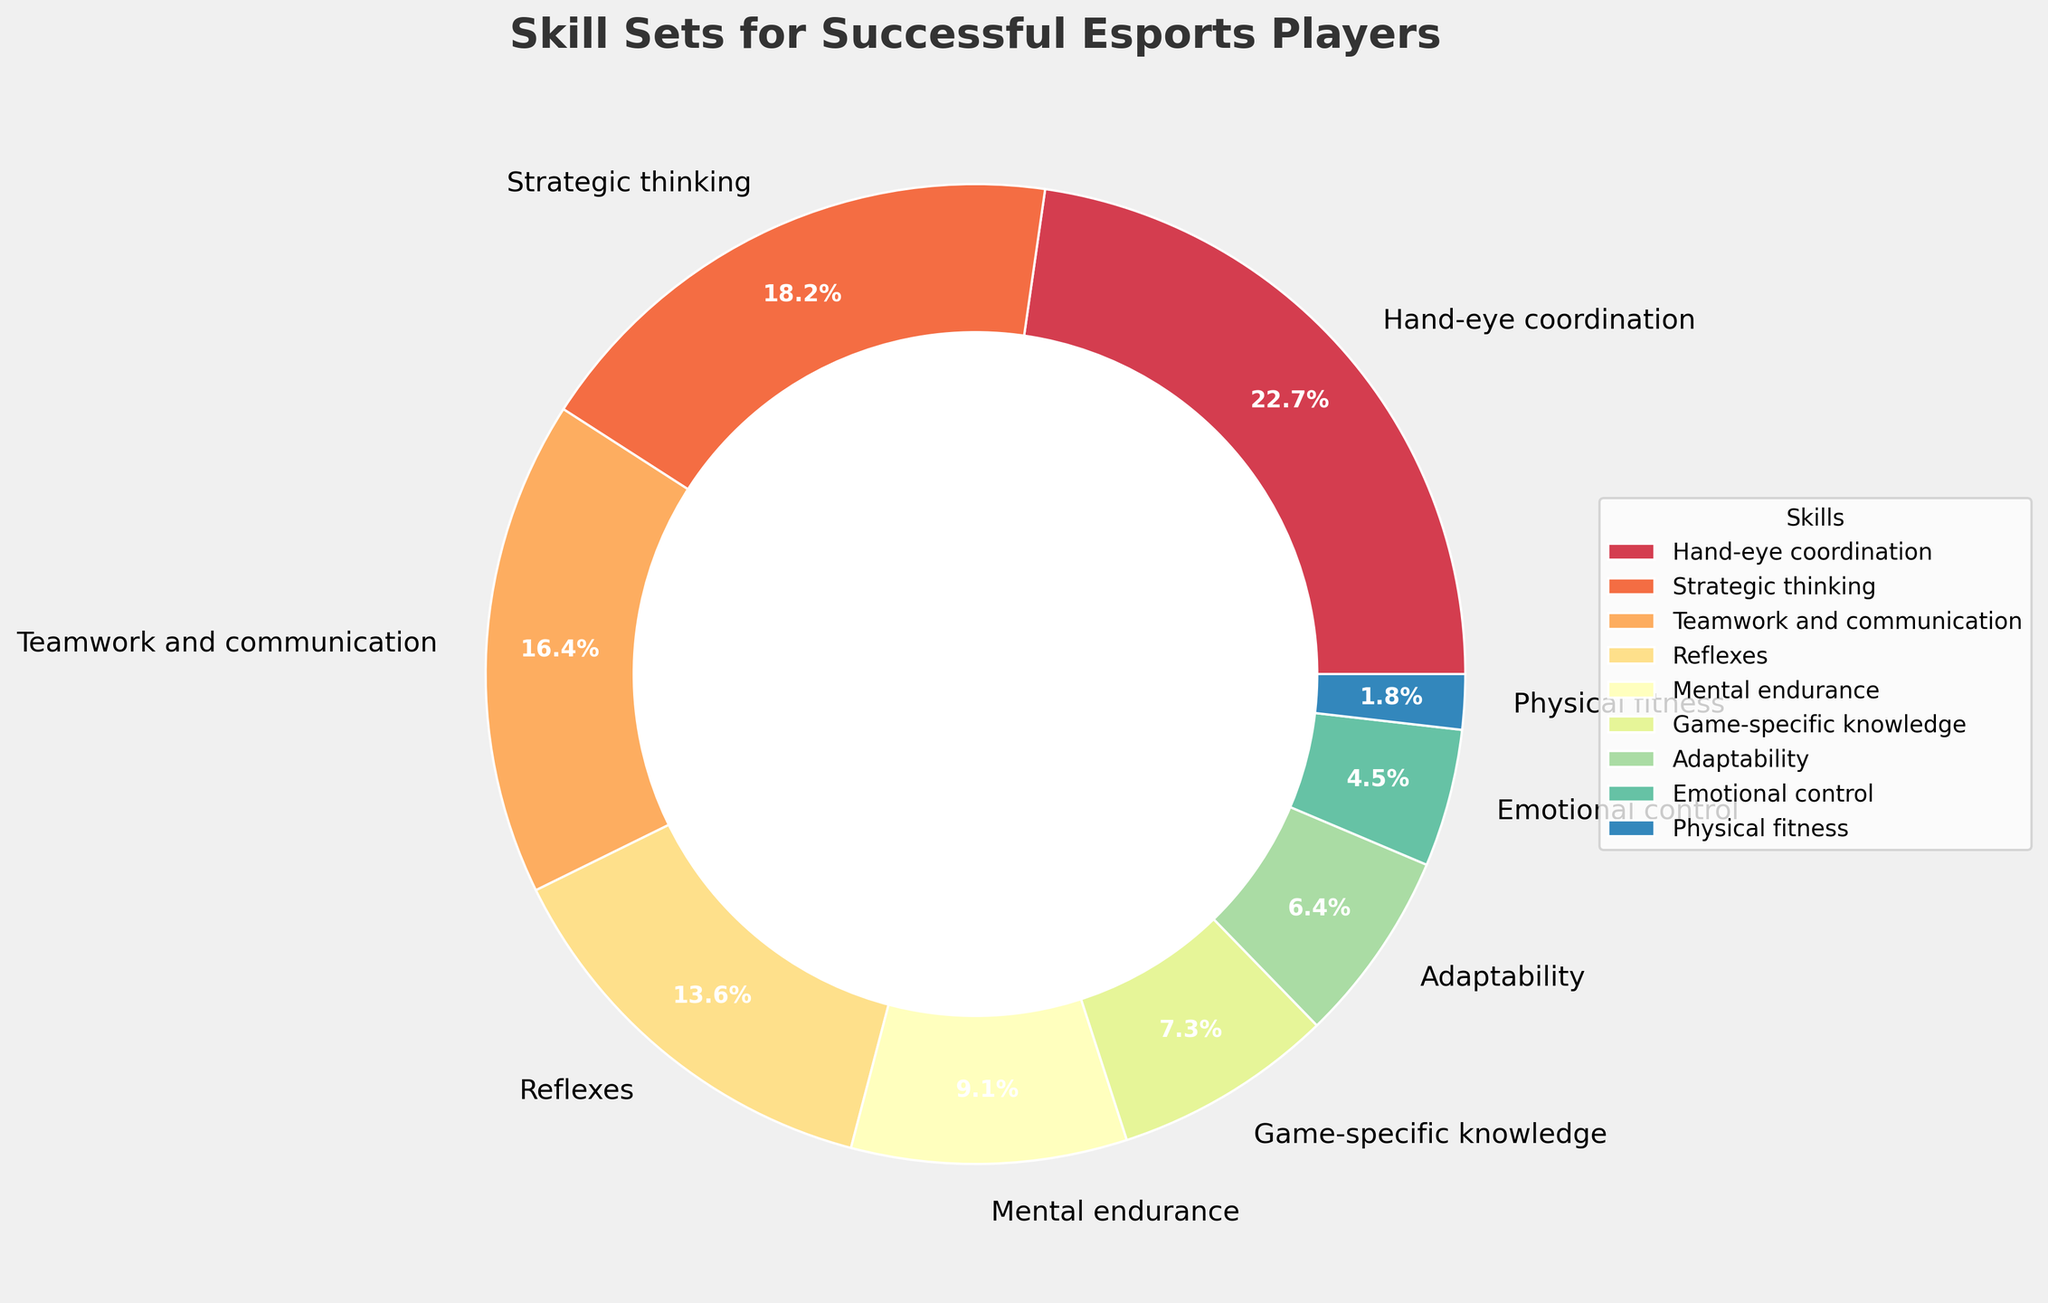Which skill has the highest percentage? The skill with the biggest slice in the pie chart is Hand-eye coordination, indicated by its larger size and the label showing 25%.
Answer: Hand-eye coordination Which skill makes up 10% of the required skill set? By looking at the labels on the pie chart, Mental endurance is the skill marked with a 10% slice.
Answer: Mental endurance What is the combined percentage of Game-specific knowledge, Adaptability, and Emotional control? Adding the percentages of Game-specific knowledge (8%), Adaptability (7%), and Emotional control (5%) gives 8 + 7 + 5 = 20%.
Answer: 20% Which skills are more significant than Adaptability but less than Hand-eye coordination? Referring to the percentages, strategic thinking (20%), teamwork and communication (18%), and reflexes (15%) are all more significant than Adaptability (7%) but less than Hand-eye coordination (25%).
Answer: Strategic thinking, teamwork and communication, reflexes What is the difference in percentage between Teamwork and communication and Reflexes? Teamwork and communication is 18% and Reflexes is 15%. The difference is 18% - 15% = 3%.
Answer: 3% What is the total percentage of the top three skills? The top three skills are Hand-eye coordination (25%), Strategic thinking (20%), and Teamwork and communication (18%). Adding them together gives 25 + 20 + 18 = 63%.
Answer: 63% Which skill has the smallest percentage? The smallest slice of the pie chart represents Physical fitness at 2%.
Answer: Physical fitness How does the percentage of Mental endurance compare to Emotional control? Mental endurance represents 10%, while Emotional control represents 5%, making Mental endurance twice as significant as Emotional control.
Answer: Mental endurance is twice as significant as Emotional control 